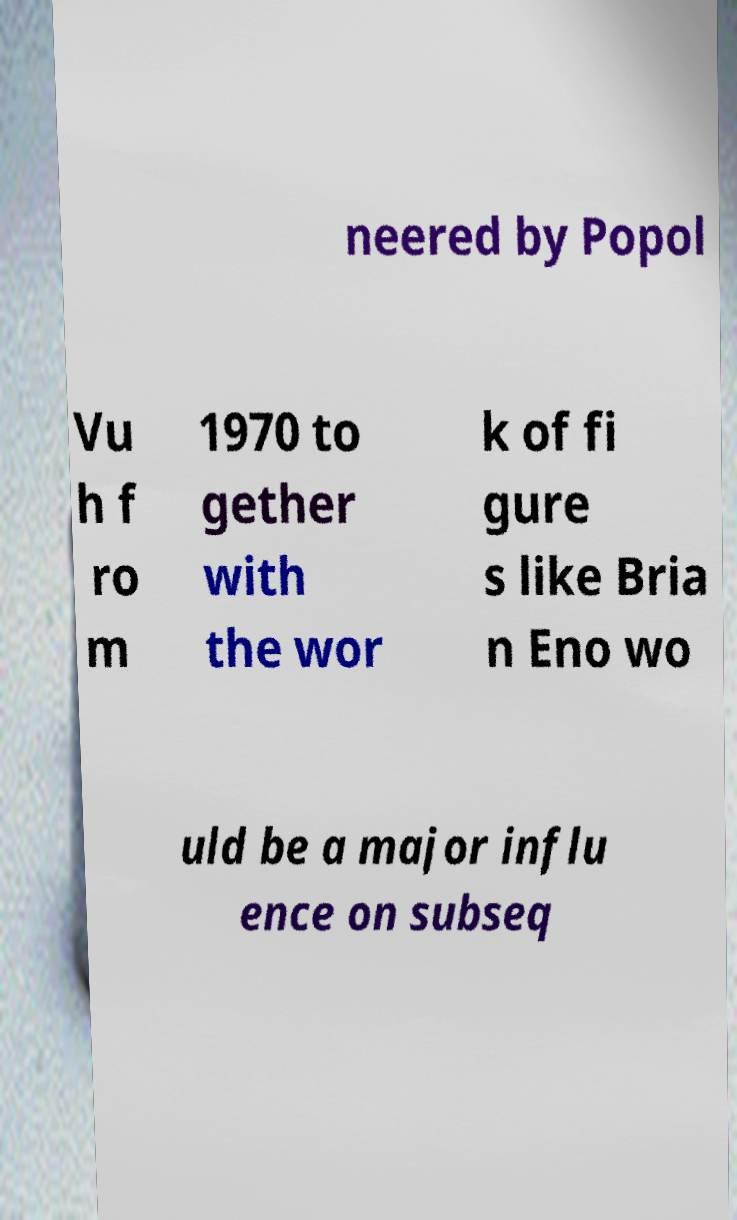For documentation purposes, I need the text within this image transcribed. Could you provide that? neered by Popol Vu h f ro m 1970 to gether with the wor k of fi gure s like Bria n Eno wo uld be a major influ ence on subseq 